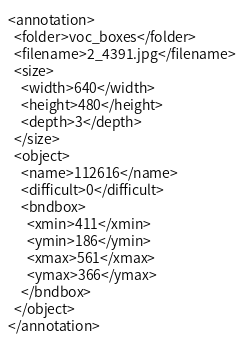<code> <loc_0><loc_0><loc_500><loc_500><_XML_><annotation>
  <folder>voc_boxes</folder>
  <filename>2_4391.jpg</filename>
  <size>
    <width>640</width>
    <height>480</height>
    <depth>3</depth>
  </size>
  <object>
    <name>112616</name>
    <difficult>0</difficult>
    <bndbox>
      <xmin>411</xmin>
      <ymin>186</ymin>
      <xmax>561</xmax>
      <ymax>366</ymax>
    </bndbox>
  </object>
</annotation></code> 